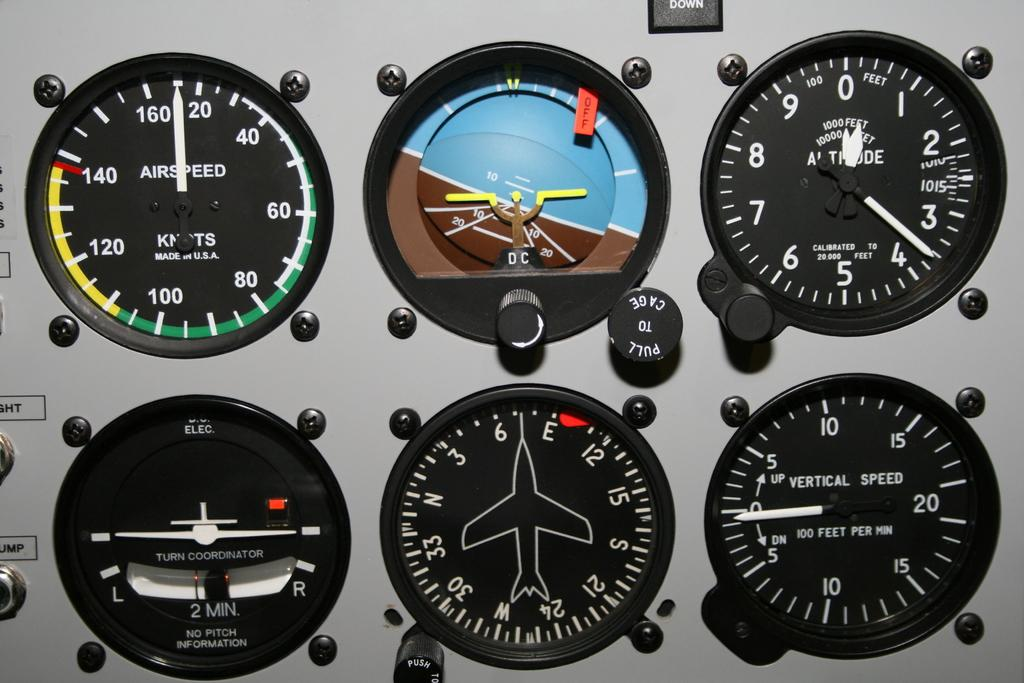<image>
Offer a succinct explanation of the picture presented. The circle on the top left measures air speed. 